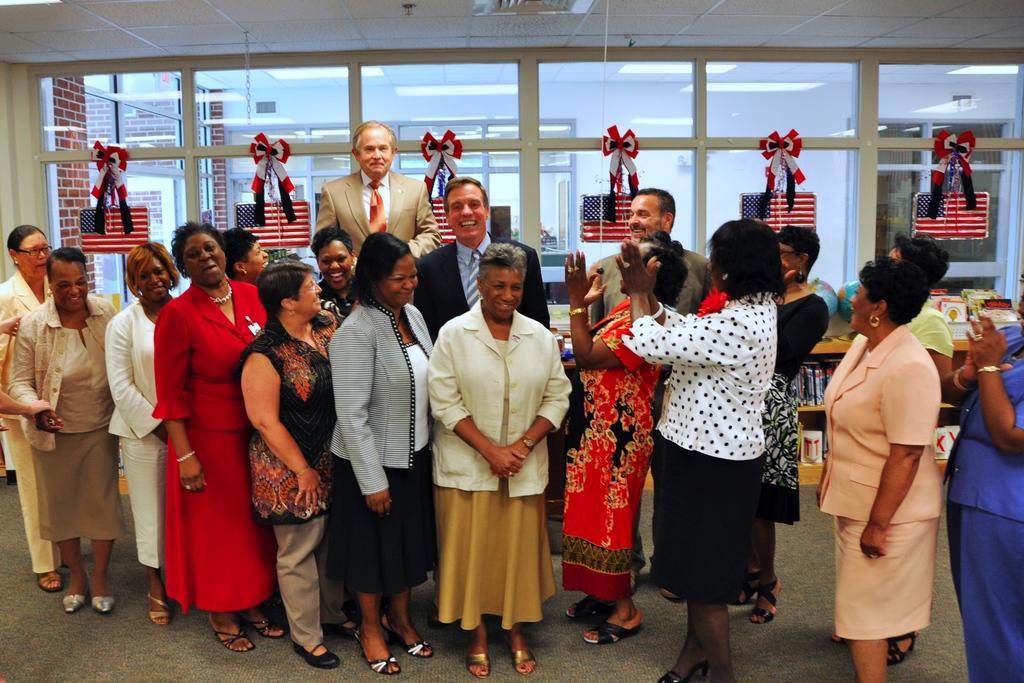How would you summarize this image in a sentence or two? As we can see in the image there are windows, wall and group of people standing. 